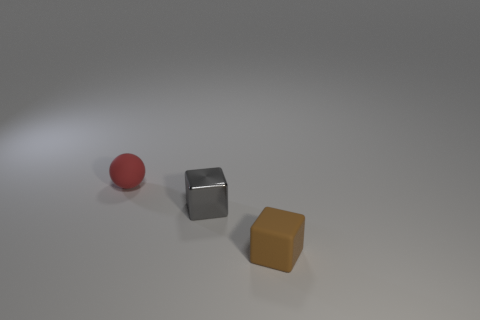Subtract all balls. How many objects are left? 2 Subtract 2 cubes. How many cubes are left? 0 Subtract all green balls. Subtract all yellow cubes. How many balls are left? 1 Subtract all cyan cylinders. How many brown cubes are left? 1 Subtract all big cyan spheres. Subtract all small metallic blocks. How many objects are left? 2 Add 3 gray things. How many gray things are left? 4 Add 2 small gray things. How many small gray things exist? 3 Add 1 tiny brown rubber blocks. How many objects exist? 4 Subtract all brown cubes. How many cubes are left? 1 Subtract 0 yellow balls. How many objects are left? 3 